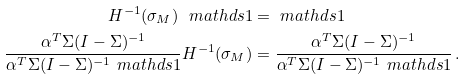Convert formula to latex. <formula><loc_0><loc_0><loc_500><loc_500>H ^ { - 1 } ( \sigma _ { M } ) \ m a t h d s { 1 } & = \ m a t h d s { 1 } \\ \frac { \alpha ^ { T } \Sigma ( I - \Sigma ) ^ { - 1 } } { \alpha ^ { T } \Sigma ( I - \Sigma ) ^ { - 1 } \ m a t h d s { 1 } } H ^ { - 1 } ( \sigma _ { M } ) & = \frac { \alpha ^ { T } \Sigma ( I - \Sigma ) ^ { - 1 } } { \alpha ^ { T } \Sigma ( I - \Sigma ) ^ { - 1 } \ m a t h d s { 1 } } \, .</formula> 